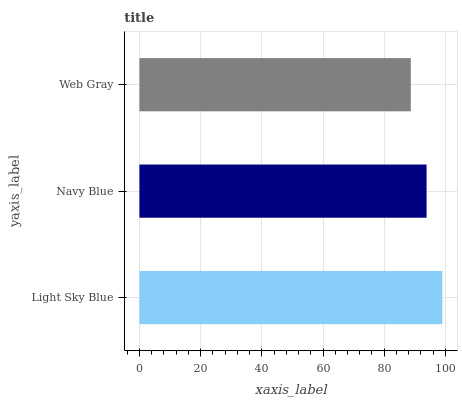Is Web Gray the minimum?
Answer yes or no. Yes. Is Light Sky Blue the maximum?
Answer yes or no. Yes. Is Navy Blue the minimum?
Answer yes or no. No. Is Navy Blue the maximum?
Answer yes or no. No. Is Light Sky Blue greater than Navy Blue?
Answer yes or no. Yes. Is Navy Blue less than Light Sky Blue?
Answer yes or no. Yes. Is Navy Blue greater than Light Sky Blue?
Answer yes or no. No. Is Light Sky Blue less than Navy Blue?
Answer yes or no. No. Is Navy Blue the high median?
Answer yes or no. Yes. Is Navy Blue the low median?
Answer yes or no. Yes. Is Web Gray the high median?
Answer yes or no. No. Is Web Gray the low median?
Answer yes or no. No. 